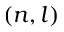<formula> <loc_0><loc_0><loc_500><loc_500>( n , l )</formula> 